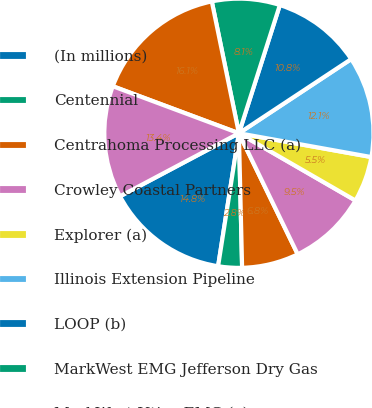Convert chart to OTSL. <chart><loc_0><loc_0><loc_500><loc_500><pie_chart><fcel>(In millions)<fcel>Centennial<fcel>Centrahoma Processing LLC (a)<fcel>Crowley Coastal Partners<fcel>Explorer (a)<fcel>Illinois Extension Pipeline<fcel>LOOP (b)<fcel>MarkWest EMG Jefferson Dry Gas<fcel>MarkWest Utica EMG (a)<fcel>PFJ Southeast<nl><fcel>14.77%<fcel>2.85%<fcel>6.82%<fcel>9.47%<fcel>5.5%<fcel>12.12%<fcel>10.79%<fcel>8.15%<fcel>16.09%<fcel>13.44%<nl></chart> 